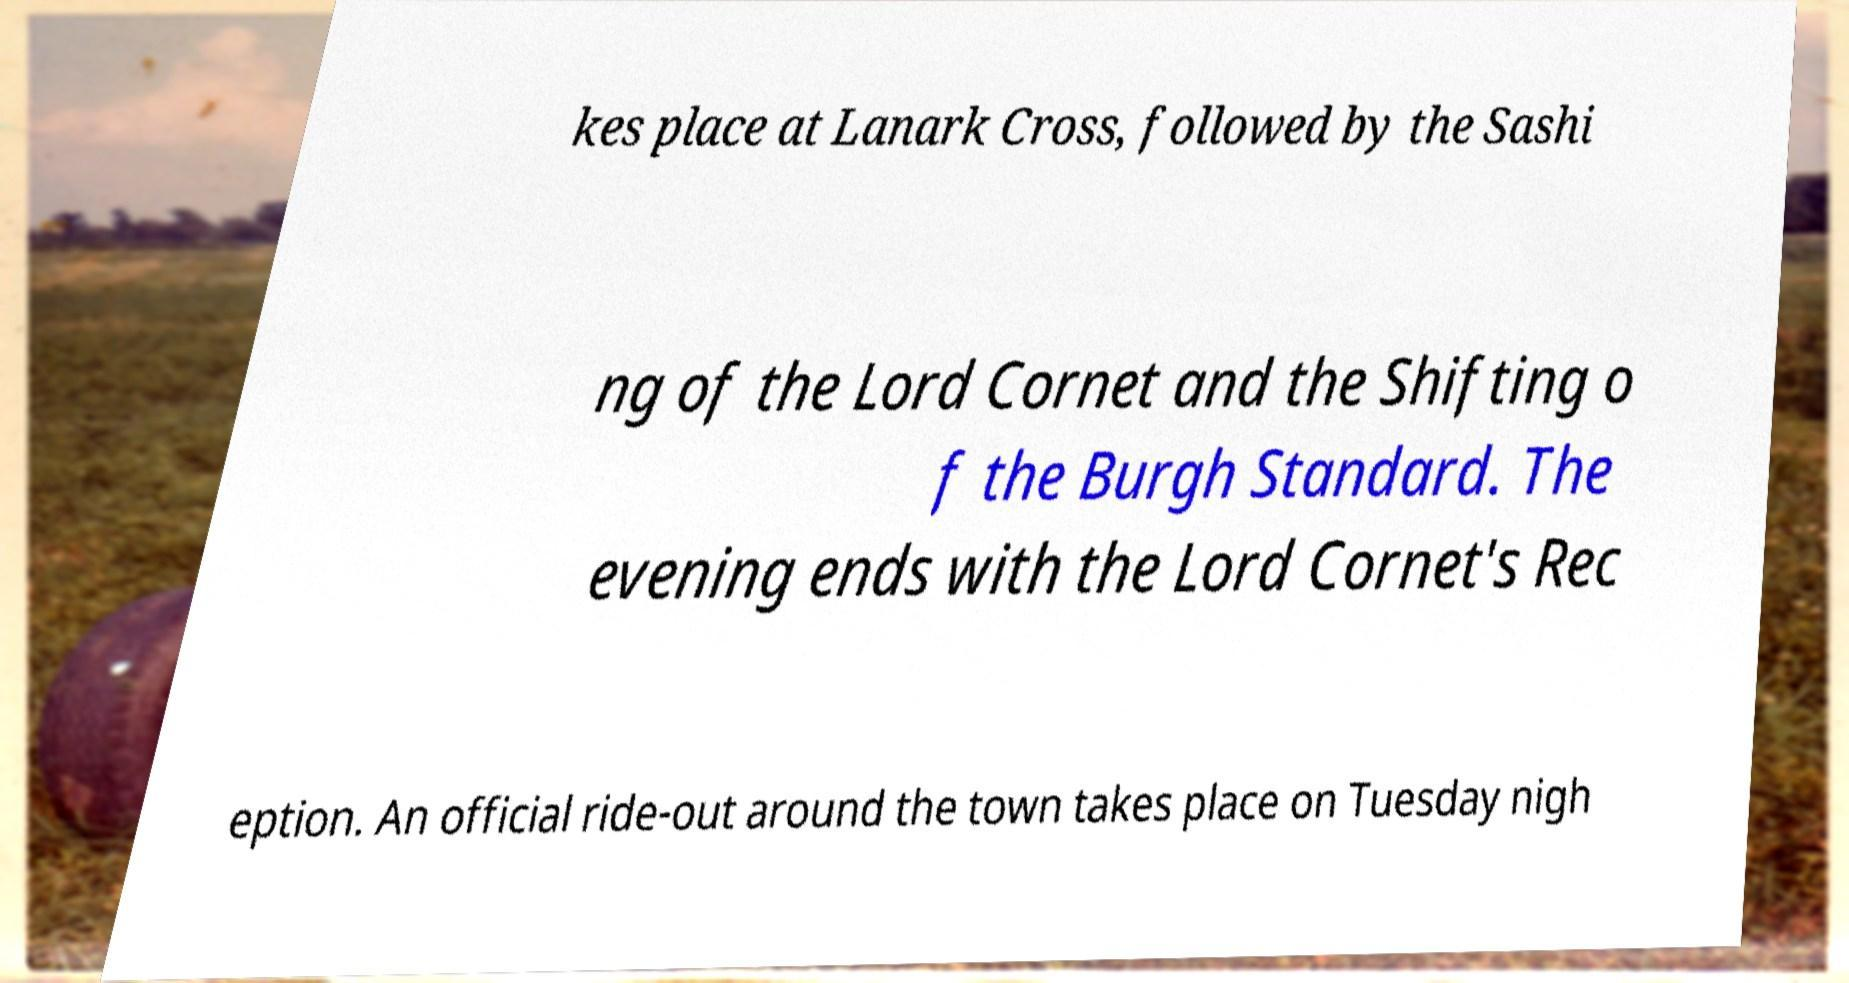Can you accurately transcribe the text from the provided image for me? kes place at Lanark Cross, followed by the Sashi ng of the Lord Cornet and the Shifting o f the Burgh Standard. The evening ends with the Lord Cornet's Rec eption. An official ride-out around the town takes place on Tuesday nigh 